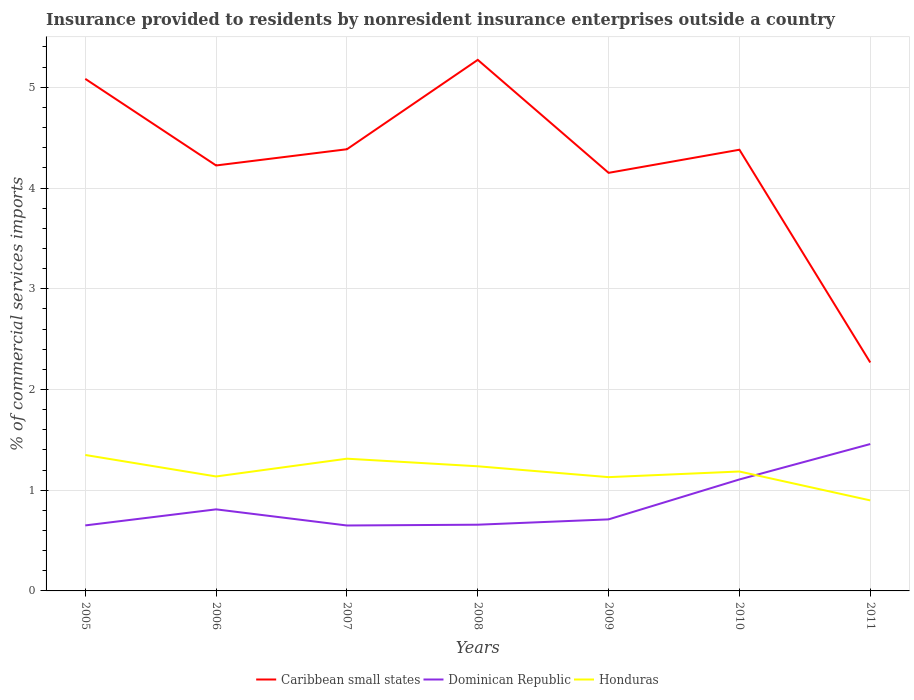How many different coloured lines are there?
Offer a terse response. 3. Does the line corresponding to Honduras intersect with the line corresponding to Caribbean small states?
Your response must be concise. No. Is the number of lines equal to the number of legend labels?
Keep it short and to the point. Yes. Across all years, what is the maximum Insurance provided to residents in Dominican Republic?
Your response must be concise. 0.65. In which year was the Insurance provided to residents in Caribbean small states maximum?
Your answer should be very brief. 2011. What is the total Insurance provided to residents in Honduras in the graph?
Give a very brief answer. 0.16. What is the difference between the highest and the second highest Insurance provided to residents in Caribbean small states?
Your response must be concise. 3. What is the difference between the highest and the lowest Insurance provided to residents in Dominican Republic?
Provide a succinct answer. 2. Is the Insurance provided to residents in Honduras strictly greater than the Insurance provided to residents in Dominican Republic over the years?
Ensure brevity in your answer.  No. How many lines are there?
Your answer should be compact. 3. What is the difference between two consecutive major ticks on the Y-axis?
Keep it short and to the point. 1. Where does the legend appear in the graph?
Offer a very short reply. Bottom center. How are the legend labels stacked?
Provide a succinct answer. Horizontal. What is the title of the graph?
Provide a succinct answer. Insurance provided to residents by nonresident insurance enterprises outside a country. Does "Cuba" appear as one of the legend labels in the graph?
Provide a short and direct response. No. What is the label or title of the X-axis?
Offer a terse response. Years. What is the label or title of the Y-axis?
Your answer should be very brief. % of commercial services imports. What is the % of commercial services imports in Caribbean small states in 2005?
Ensure brevity in your answer.  5.08. What is the % of commercial services imports of Dominican Republic in 2005?
Your answer should be very brief. 0.65. What is the % of commercial services imports in Honduras in 2005?
Ensure brevity in your answer.  1.35. What is the % of commercial services imports in Caribbean small states in 2006?
Your response must be concise. 4.22. What is the % of commercial services imports of Dominican Republic in 2006?
Ensure brevity in your answer.  0.81. What is the % of commercial services imports in Honduras in 2006?
Offer a very short reply. 1.14. What is the % of commercial services imports of Caribbean small states in 2007?
Your response must be concise. 4.38. What is the % of commercial services imports in Dominican Republic in 2007?
Your answer should be compact. 0.65. What is the % of commercial services imports of Honduras in 2007?
Offer a very short reply. 1.31. What is the % of commercial services imports in Caribbean small states in 2008?
Make the answer very short. 5.27. What is the % of commercial services imports of Dominican Republic in 2008?
Provide a short and direct response. 0.66. What is the % of commercial services imports of Honduras in 2008?
Offer a very short reply. 1.24. What is the % of commercial services imports of Caribbean small states in 2009?
Keep it short and to the point. 4.15. What is the % of commercial services imports of Dominican Republic in 2009?
Provide a short and direct response. 0.71. What is the % of commercial services imports in Honduras in 2009?
Give a very brief answer. 1.13. What is the % of commercial services imports of Caribbean small states in 2010?
Make the answer very short. 4.38. What is the % of commercial services imports in Dominican Republic in 2010?
Offer a very short reply. 1.11. What is the % of commercial services imports of Honduras in 2010?
Make the answer very short. 1.19. What is the % of commercial services imports in Caribbean small states in 2011?
Your answer should be compact. 2.27. What is the % of commercial services imports in Dominican Republic in 2011?
Offer a terse response. 1.46. What is the % of commercial services imports in Honduras in 2011?
Give a very brief answer. 0.9. Across all years, what is the maximum % of commercial services imports of Caribbean small states?
Your response must be concise. 5.27. Across all years, what is the maximum % of commercial services imports in Dominican Republic?
Your answer should be very brief. 1.46. Across all years, what is the maximum % of commercial services imports in Honduras?
Provide a succinct answer. 1.35. Across all years, what is the minimum % of commercial services imports of Caribbean small states?
Offer a terse response. 2.27. Across all years, what is the minimum % of commercial services imports of Dominican Republic?
Your answer should be compact. 0.65. Across all years, what is the minimum % of commercial services imports of Honduras?
Make the answer very short. 0.9. What is the total % of commercial services imports of Caribbean small states in the graph?
Provide a short and direct response. 29.76. What is the total % of commercial services imports of Dominican Republic in the graph?
Offer a terse response. 6.04. What is the total % of commercial services imports in Honduras in the graph?
Ensure brevity in your answer.  8.25. What is the difference between the % of commercial services imports in Caribbean small states in 2005 and that in 2006?
Ensure brevity in your answer.  0.86. What is the difference between the % of commercial services imports in Dominican Republic in 2005 and that in 2006?
Offer a very short reply. -0.16. What is the difference between the % of commercial services imports in Honduras in 2005 and that in 2006?
Offer a terse response. 0.21. What is the difference between the % of commercial services imports in Caribbean small states in 2005 and that in 2007?
Provide a short and direct response. 0.7. What is the difference between the % of commercial services imports in Dominican Republic in 2005 and that in 2007?
Offer a very short reply. 0. What is the difference between the % of commercial services imports in Honduras in 2005 and that in 2007?
Give a very brief answer. 0.04. What is the difference between the % of commercial services imports of Caribbean small states in 2005 and that in 2008?
Offer a very short reply. -0.19. What is the difference between the % of commercial services imports of Dominican Republic in 2005 and that in 2008?
Your answer should be very brief. -0.01. What is the difference between the % of commercial services imports in Honduras in 2005 and that in 2008?
Your response must be concise. 0.11. What is the difference between the % of commercial services imports of Caribbean small states in 2005 and that in 2009?
Your answer should be very brief. 0.93. What is the difference between the % of commercial services imports of Dominican Republic in 2005 and that in 2009?
Give a very brief answer. -0.06. What is the difference between the % of commercial services imports of Honduras in 2005 and that in 2009?
Your response must be concise. 0.22. What is the difference between the % of commercial services imports of Caribbean small states in 2005 and that in 2010?
Give a very brief answer. 0.7. What is the difference between the % of commercial services imports of Dominican Republic in 2005 and that in 2010?
Offer a very short reply. -0.46. What is the difference between the % of commercial services imports of Honduras in 2005 and that in 2010?
Your answer should be compact. 0.16. What is the difference between the % of commercial services imports of Caribbean small states in 2005 and that in 2011?
Offer a terse response. 2.82. What is the difference between the % of commercial services imports of Dominican Republic in 2005 and that in 2011?
Give a very brief answer. -0.81. What is the difference between the % of commercial services imports of Honduras in 2005 and that in 2011?
Keep it short and to the point. 0.45. What is the difference between the % of commercial services imports in Caribbean small states in 2006 and that in 2007?
Your response must be concise. -0.16. What is the difference between the % of commercial services imports of Dominican Republic in 2006 and that in 2007?
Ensure brevity in your answer.  0.16. What is the difference between the % of commercial services imports of Honduras in 2006 and that in 2007?
Keep it short and to the point. -0.18. What is the difference between the % of commercial services imports in Caribbean small states in 2006 and that in 2008?
Provide a short and direct response. -1.05. What is the difference between the % of commercial services imports of Dominican Republic in 2006 and that in 2008?
Offer a terse response. 0.15. What is the difference between the % of commercial services imports of Honduras in 2006 and that in 2008?
Your answer should be very brief. -0.1. What is the difference between the % of commercial services imports of Caribbean small states in 2006 and that in 2009?
Your response must be concise. 0.07. What is the difference between the % of commercial services imports in Dominican Republic in 2006 and that in 2009?
Ensure brevity in your answer.  0.1. What is the difference between the % of commercial services imports in Honduras in 2006 and that in 2009?
Your response must be concise. 0.01. What is the difference between the % of commercial services imports of Caribbean small states in 2006 and that in 2010?
Offer a terse response. -0.16. What is the difference between the % of commercial services imports in Dominican Republic in 2006 and that in 2010?
Your answer should be compact. -0.3. What is the difference between the % of commercial services imports of Honduras in 2006 and that in 2010?
Offer a terse response. -0.05. What is the difference between the % of commercial services imports of Caribbean small states in 2006 and that in 2011?
Provide a succinct answer. 1.96. What is the difference between the % of commercial services imports of Dominican Republic in 2006 and that in 2011?
Your response must be concise. -0.65. What is the difference between the % of commercial services imports in Honduras in 2006 and that in 2011?
Keep it short and to the point. 0.24. What is the difference between the % of commercial services imports of Caribbean small states in 2007 and that in 2008?
Give a very brief answer. -0.89. What is the difference between the % of commercial services imports in Dominican Republic in 2007 and that in 2008?
Offer a very short reply. -0.01. What is the difference between the % of commercial services imports of Honduras in 2007 and that in 2008?
Your answer should be compact. 0.08. What is the difference between the % of commercial services imports of Caribbean small states in 2007 and that in 2009?
Offer a terse response. 0.23. What is the difference between the % of commercial services imports in Dominican Republic in 2007 and that in 2009?
Your answer should be compact. -0.06. What is the difference between the % of commercial services imports of Honduras in 2007 and that in 2009?
Offer a terse response. 0.18. What is the difference between the % of commercial services imports of Caribbean small states in 2007 and that in 2010?
Your response must be concise. 0. What is the difference between the % of commercial services imports in Dominican Republic in 2007 and that in 2010?
Your answer should be very brief. -0.46. What is the difference between the % of commercial services imports of Honduras in 2007 and that in 2010?
Give a very brief answer. 0.13. What is the difference between the % of commercial services imports in Caribbean small states in 2007 and that in 2011?
Your answer should be compact. 2.12. What is the difference between the % of commercial services imports in Dominican Republic in 2007 and that in 2011?
Provide a succinct answer. -0.81. What is the difference between the % of commercial services imports in Honduras in 2007 and that in 2011?
Offer a terse response. 0.41. What is the difference between the % of commercial services imports in Caribbean small states in 2008 and that in 2009?
Give a very brief answer. 1.12. What is the difference between the % of commercial services imports in Dominican Republic in 2008 and that in 2009?
Make the answer very short. -0.05. What is the difference between the % of commercial services imports of Honduras in 2008 and that in 2009?
Make the answer very short. 0.11. What is the difference between the % of commercial services imports in Caribbean small states in 2008 and that in 2010?
Keep it short and to the point. 0.89. What is the difference between the % of commercial services imports of Dominican Republic in 2008 and that in 2010?
Give a very brief answer. -0.45. What is the difference between the % of commercial services imports in Honduras in 2008 and that in 2010?
Provide a succinct answer. 0.05. What is the difference between the % of commercial services imports of Caribbean small states in 2008 and that in 2011?
Ensure brevity in your answer.  3. What is the difference between the % of commercial services imports in Dominican Republic in 2008 and that in 2011?
Your answer should be very brief. -0.8. What is the difference between the % of commercial services imports of Honduras in 2008 and that in 2011?
Give a very brief answer. 0.34. What is the difference between the % of commercial services imports of Caribbean small states in 2009 and that in 2010?
Your response must be concise. -0.23. What is the difference between the % of commercial services imports of Dominican Republic in 2009 and that in 2010?
Your answer should be compact. -0.4. What is the difference between the % of commercial services imports in Honduras in 2009 and that in 2010?
Make the answer very short. -0.06. What is the difference between the % of commercial services imports in Caribbean small states in 2009 and that in 2011?
Offer a very short reply. 1.88. What is the difference between the % of commercial services imports of Dominican Republic in 2009 and that in 2011?
Provide a short and direct response. -0.75. What is the difference between the % of commercial services imports in Honduras in 2009 and that in 2011?
Your answer should be very brief. 0.23. What is the difference between the % of commercial services imports of Caribbean small states in 2010 and that in 2011?
Keep it short and to the point. 2.11. What is the difference between the % of commercial services imports in Dominican Republic in 2010 and that in 2011?
Keep it short and to the point. -0.35. What is the difference between the % of commercial services imports of Honduras in 2010 and that in 2011?
Give a very brief answer. 0.29. What is the difference between the % of commercial services imports of Caribbean small states in 2005 and the % of commercial services imports of Dominican Republic in 2006?
Make the answer very short. 4.27. What is the difference between the % of commercial services imports of Caribbean small states in 2005 and the % of commercial services imports of Honduras in 2006?
Make the answer very short. 3.95. What is the difference between the % of commercial services imports in Dominican Republic in 2005 and the % of commercial services imports in Honduras in 2006?
Provide a short and direct response. -0.49. What is the difference between the % of commercial services imports in Caribbean small states in 2005 and the % of commercial services imports in Dominican Republic in 2007?
Make the answer very short. 4.43. What is the difference between the % of commercial services imports in Caribbean small states in 2005 and the % of commercial services imports in Honduras in 2007?
Your answer should be compact. 3.77. What is the difference between the % of commercial services imports in Dominican Republic in 2005 and the % of commercial services imports in Honduras in 2007?
Offer a terse response. -0.66. What is the difference between the % of commercial services imports of Caribbean small states in 2005 and the % of commercial services imports of Dominican Republic in 2008?
Provide a short and direct response. 4.43. What is the difference between the % of commercial services imports of Caribbean small states in 2005 and the % of commercial services imports of Honduras in 2008?
Give a very brief answer. 3.85. What is the difference between the % of commercial services imports of Dominican Republic in 2005 and the % of commercial services imports of Honduras in 2008?
Your response must be concise. -0.59. What is the difference between the % of commercial services imports in Caribbean small states in 2005 and the % of commercial services imports in Dominican Republic in 2009?
Provide a succinct answer. 4.37. What is the difference between the % of commercial services imports in Caribbean small states in 2005 and the % of commercial services imports in Honduras in 2009?
Offer a very short reply. 3.95. What is the difference between the % of commercial services imports in Dominican Republic in 2005 and the % of commercial services imports in Honduras in 2009?
Offer a very short reply. -0.48. What is the difference between the % of commercial services imports in Caribbean small states in 2005 and the % of commercial services imports in Dominican Republic in 2010?
Keep it short and to the point. 3.98. What is the difference between the % of commercial services imports of Caribbean small states in 2005 and the % of commercial services imports of Honduras in 2010?
Provide a short and direct response. 3.9. What is the difference between the % of commercial services imports of Dominican Republic in 2005 and the % of commercial services imports of Honduras in 2010?
Your answer should be compact. -0.54. What is the difference between the % of commercial services imports of Caribbean small states in 2005 and the % of commercial services imports of Dominican Republic in 2011?
Provide a succinct answer. 3.63. What is the difference between the % of commercial services imports of Caribbean small states in 2005 and the % of commercial services imports of Honduras in 2011?
Your response must be concise. 4.18. What is the difference between the % of commercial services imports of Dominican Republic in 2005 and the % of commercial services imports of Honduras in 2011?
Ensure brevity in your answer.  -0.25. What is the difference between the % of commercial services imports in Caribbean small states in 2006 and the % of commercial services imports in Dominican Republic in 2007?
Provide a short and direct response. 3.57. What is the difference between the % of commercial services imports of Caribbean small states in 2006 and the % of commercial services imports of Honduras in 2007?
Make the answer very short. 2.91. What is the difference between the % of commercial services imports in Dominican Republic in 2006 and the % of commercial services imports in Honduras in 2007?
Keep it short and to the point. -0.5. What is the difference between the % of commercial services imports of Caribbean small states in 2006 and the % of commercial services imports of Dominican Republic in 2008?
Provide a succinct answer. 3.57. What is the difference between the % of commercial services imports of Caribbean small states in 2006 and the % of commercial services imports of Honduras in 2008?
Your response must be concise. 2.99. What is the difference between the % of commercial services imports of Dominican Republic in 2006 and the % of commercial services imports of Honduras in 2008?
Provide a succinct answer. -0.43. What is the difference between the % of commercial services imports in Caribbean small states in 2006 and the % of commercial services imports in Dominican Republic in 2009?
Your response must be concise. 3.51. What is the difference between the % of commercial services imports in Caribbean small states in 2006 and the % of commercial services imports in Honduras in 2009?
Provide a short and direct response. 3.09. What is the difference between the % of commercial services imports of Dominican Republic in 2006 and the % of commercial services imports of Honduras in 2009?
Provide a short and direct response. -0.32. What is the difference between the % of commercial services imports in Caribbean small states in 2006 and the % of commercial services imports in Dominican Republic in 2010?
Offer a terse response. 3.12. What is the difference between the % of commercial services imports in Caribbean small states in 2006 and the % of commercial services imports in Honduras in 2010?
Give a very brief answer. 3.04. What is the difference between the % of commercial services imports of Dominican Republic in 2006 and the % of commercial services imports of Honduras in 2010?
Make the answer very short. -0.38. What is the difference between the % of commercial services imports in Caribbean small states in 2006 and the % of commercial services imports in Dominican Republic in 2011?
Provide a short and direct response. 2.77. What is the difference between the % of commercial services imports of Caribbean small states in 2006 and the % of commercial services imports of Honduras in 2011?
Your answer should be compact. 3.33. What is the difference between the % of commercial services imports of Dominican Republic in 2006 and the % of commercial services imports of Honduras in 2011?
Ensure brevity in your answer.  -0.09. What is the difference between the % of commercial services imports of Caribbean small states in 2007 and the % of commercial services imports of Dominican Republic in 2008?
Your answer should be very brief. 3.73. What is the difference between the % of commercial services imports in Caribbean small states in 2007 and the % of commercial services imports in Honduras in 2008?
Make the answer very short. 3.15. What is the difference between the % of commercial services imports in Dominican Republic in 2007 and the % of commercial services imports in Honduras in 2008?
Make the answer very short. -0.59. What is the difference between the % of commercial services imports in Caribbean small states in 2007 and the % of commercial services imports in Dominican Republic in 2009?
Give a very brief answer. 3.67. What is the difference between the % of commercial services imports of Caribbean small states in 2007 and the % of commercial services imports of Honduras in 2009?
Provide a succinct answer. 3.26. What is the difference between the % of commercial services imports in Dominican Republic in 2007 and the % of commercial services imports in Honduras in 2009?
Your answer should be compact. -0.48. What is the difference between the % of commercial services imports of Caribbean small states in 2007 and the % of commercial services imports of Dominican Republic in 2010?
Ensure brevity in your answer.  3.28. What is the difference between the % of commercial services imports in Caribbean small states in 2007 and the % of commercial services imports in Honduras in 2010?
Provide a short and direct response. 3.2. What is the difference between the % of commercial services imports in Dominican Republic in 2007 and the % of commercial services imports in Honduras in 2010?
Keep it short and to the point. -0.54. What is the difference between the % of commercial services imports of Caribbean small states in 2007 and the % of commercial services imports of Dominican Republic in 2011?
Keep it short and to the point. 2.93. What is the difference between the % of commercial services imports of Caribbean small states in 2007 and the % of commercial services imports of Honduras in 2011?
Offer a very short reply. 3.49. What is the difference between the % of commercial services imports in Dominican Republic in 2007 and the % of commercial services imports in Honduras in 2011?
Provide a short and direct response. -0.25. What is the difference between the % of commercial services imports of Caribbean small states in 2008 and the % of commercial services imports of Dominican Republic in 2009?
Your response must be concise. 4.56. What is the difference between the % of commercial services imports of Caribbean small states in 2008 and the % of commercial services imports of Honduras in 2009?
Your answer should be compact. 4.14. What is the difference between the % of commercial services imports in Dominican Republic in 2008 and the % of commercial services imports in Honduras in 2009?
Provide a short and direct response. -0.47. What is the difference between the % of commercial services imports of Caribbean small states in 2008 and the % of commercial services imports of Dominican Republic in 2010?
Make the answer very short. 4.17. What is the difference between the % of commercial services imports in Caribbean small states in 2008 and the % of commercial services imports in Honduras in 2010?
Keep it short and to the point. 4.09. What is the difference between the % of commercial services imports of Dominican Republic in 2008 and the % of commercial services imports of Honduras in 2010?
Keep it short and to the point. -0.53. What is the difference between the % of commercial services imports of Caribbean small states in 2008 and the % of commercial services imports of Dominican Republic in 2011?
Make the answer very short. 3.81. What is the difference between the % of commercial services imports in Caribbean small states in 2008 and the % of commercial services imports in Honduras in 2011?
Your response must be concise. 4.37. What is the difference between the % of commercial services imports in Dominican Republic in 2008 and the % of commercial services imports in Honduras in 2011?
Offer a terse response. -0.24. What is the difference between the % of commercial services imports of Caribbean small states in 2009 and the % of commercial services imports of Dominican Republic in 2010?
Ensure brevity in your answer.  3.04. What is the difference between the % of commercial services imports of Caribbean small states in 2009 and the % of commercial services imports of Honduras in 2010?
Your answer should be compact. 2.96. What is the difference between the % of commercial services imports in Dominican Republic in 2009 and the % of commercial services imports in Honduras in 2010?
Offer a terse response. -0.48. What is the difference between the % of commercial services imports in Caribbean small states in 2009 and the % of commercial services imports in Dominican Republic in 2011?
Provide a succinct answer. 2.69. What is the difference between the % of commercial services imports in Caribbean small states in 2009 and the % of commercial services imports in Honduras in 2011?
Give a very brief answer. 3.25. What is the difference between the % of commercial services imports of Dominican Republic in 2009 and the % of commercial services imports of Honduras in 2011?
Your answer should be compact. -0.19. What is the difference between the % of commercial services imports of Caribbean small states in 2010 and the % of commercial services imports of Dominican Republic in 2011?
Your answer should be compact. 2.92. What is the difference between the % of commercial services imports in Caribbean small states in 2010 and the % of commercial services imports in Honduras in 2011?
Your answer should be compact. 3.48. What is the difference between the % of commercial services imports in Dominican Republic in 2010 and the % of commercial services imports in Honduras in 2011?
Provide a succinct answer. 0.21. What is the average % of commercial services imports in Caribbean small states per year?
Offer a terse response. 4.25. What is the average % of commercial services imports of Dominican Republic per year?
Offer a terse response. 0.86. What is the average % of commercial services imports of Honduras per year?
Give a very brief answer. 1.18. In the year 2005, what is the difference between the % of commercial services imports of Caribbean small states and % of commercial services imports of Dominican Republic?
Give a very brief answer. 4.43. In the year 2005, what is the difference between the % of commercial services imports of Caribbean small states and % of commercial services imports of Honduras?
Provide a short and direct response. 3.73. In the year 2005, what is the difference between the % of commercial services imports in Dominican Republic and % of commercial services imports in Honduras?
Make the answer very short. -0.7. In the year 2006, what is the difference between the % of commercial services imports of Caribbean small states and % of commercial services imports of Dominican Republic?
Give a very brief answer. 3.41. In the year 2006, what is the difference between the % of commercial services imports in Caribbean small states and % of commercial services imports in Honduras?
Offer a very short reply. 3.09. In the year 2006, what is the difference between the % of commercial services imports of Dominican Republic and % of commercial services imports of Honduras?
Provide a succinct answer. -0.33. In the year 2007, what is the difference between the % of commercial services imports in Caribbean small states and % of commercial services imports in Dominican Republic?
Your response must be concise. 3.74. In the year 2007, what is the difference between the % of commercial services imports of Caribbean small states and % of commercial services imports of Honduras?
Provide a succinct answer. 3.07. In the year 2007, what is the difference between the % of commercial services imports of Dominican Republic and % of commercial services imports of Honduras?
Make the answer very short. -0.66. In the year 2008, what is the difference between the % of commercial services imports of Caribbean small states and % of commercial services imports of Dominican Republic?
Provide a short and direct response. 4.61. In the year 2008, what is the difference between the % of commercial services imports in Caribbean small states and % of commercial services imports in Honduras?
Your answer should be compact. 4.03. In the year 2008, what is the difference between the % of commercial services imports in Dominican Republic and % of commercial services imports in Honduras?
Give a very brief answer. -0.58. In the year 2009, what is the difference between the % of commercial services imports of Caribbean small states and % of commercial services imports of Dominican Republic?
Make the answer very short. 3.44. In the year 2009, what is the difference between the % of commercial services imports of Caribbean small states and % of commercial services imports of Honduras?
Your answer should be compact. 3.02. In the year 2009, what is the difference between the % of commercial services imports of Dominican Republic and % of commercial services imports of Honduras?
Make the answer very short. -0.42. In the year 2010, what is the difference between the % of commercial services imports in Caribbean small states and % of commercial services imports in Dominican Republic?
Your answer should be compact. 3.27. In the year 2010, what is the difference between the % of commercial services imports in Caribbean small states and % of commercial services imports in Honduras?
Provide a short and direct response. 3.19. In the year 2010, what is the difference between the % of commercial services imports in Dominican Republic and % of commercial services imports in Honduras?
Your response must be concise. -0.08. In the year 2011, what is the difference between the % of commercial services imports in Caribbean small states and % of commercial services imports in Dominican Republic?
Make the answer very short. 0.81. In the year 2011, what is the difference between the % of commercial services imports of Caribbean small states and % of commercial services imports of Honduras?
Ensure brevity in your answer.  1.37. In the year 2011, what is the difference between the % of commercial services imports in Dominican Republic and % of commercial services imports in Honduras?
Your answer should be very brief. 0.56. What is the ratio of the % of commercial services imports of Caribbean small states in 2005 to that in 2006?
Keep it short and to the point. 1.2. What is the ratio of the % of commercial services imports in Dominican Republic in 2005 to that in 2006?
Offer a very short reply. 0.8. What is the ratio of the % of commercial services imports in Honduras in 2005 to that in 2006?
Make the answer very short. 1.19. What is the ratio of the % of commercial services imports of Caribbean small states in 2005 to that in 2007?
Offer a terse response. 1.16. What is the ratio of the % of commercial services imports in Dominican Republic in 2005 to that in 2007?
Your answer should be very brief. 1. What is the ratio of the % of commercial services imports in Honduras in 2005 to that in 2007?
Make the answer very short. 1.03. What is the ratio of the % of commercial services imports in Caribbean small states in 2005 to that in 2008?
Ensure brevity in your answer.  0.96. What is the ratio of the % of commercial services imports in Honduras in 2005 to that in 2008?
Ensure brevity in your answer.  1.09. What is the ratio of the % of commercial services imports of Caribbean small states in 2005 to that in 2009?
Ensure brevity in your answer.  1.22. What is the ratio of the % of commercial services imports of Dominican Republic in 2005 to that in 2009?
Offer a very short reply. 0.92. What is the ratio of the % of commercial services imports in Honduras in 2005 to that in 2009?
Your answer should be compact. 1.19. What is the ratio of the % of commercial services imports of Caribbean small states in 2005 to that in 2010?
Keep it short and to the point. 1.16. What is the ratio of the % of commercial services imports of Dominican Republic in 2005 to that in 2010?
Give a very brief answer. 0.59. What is the ratio of the % of commercial services imports in Honduras in 2005 to that in 2010?
Your answer should be very brief. 1.14. What is the ratio of the % of commercial services imports in Caribbean small states in 2005 to that in 2011?
Your answer should be compact. 2.24. What is the ratio of the % of commercial services imports of Dominican Republic in 2005 to that in 2011?
Make the answer very short. 0.45. What is the ratio of the % of commercial services imports of Honduras in 2005 to that in 2011?
Ensure brevity in your answer.  1.5. What is the ratio of the % of commercial services imports in Caribbean small states in 2006 to that in 2007?
Ensure brevity in your answer.  0.96. What is the ratio of the % of commercial services imports in Dominican Republic in 2006 to that in 2007?
Your answer should be very brief. 1.25. What is the ratio of the % of commercial services imports of Honduras in 2006 to that in 2007?
Your response must be concise. 0.87. What is the ratio of the % of commercial services imports of Caribbean small states in 2006 to that in 2008?
Provide a short and direct response. 0.8. What is the ratio of the % of commercial services imports of Dominican Republic in 2006 to that in 2008?
Your response must be concise. 1.23. What is the ratio of the % of commercial services imports in Honduras in 2006 to that in 2008?
Offer a very short reply. 0.92. What is the ratio of the % of commercial services imports in Caribbean small states in 2006 to that in 2009?
Provide a succinct answer. 1.02. What is the ratio of the % of commercial services imports of Dominican Republic in 2006 to that in 2009?
Your answer should be compact. 1.14. What is the ratio of the % of commercial services imports in Dominican Republic in 2006 to that in 2010?
Your answer should be very brief. 0.73. What is the ratio of the % of commercial services imports in Honduras in 2006 to that in 2010?
Offer a very short reply. 0.96. What is the ratio of the % of commercial services imports in Caribbean small states in 2006 to that in 2011?
Offer a very short reply. 1.86. What is the ratio of the % of commercial services imports of Dominican Republic in 2006 to that in 2011?
Ensure brevity in your answer.  0.56. What is the ratio of the % of commercial services imports of Honduras in 2006 to that in 2011?
Make the answer very short. 1.26. What is the ratio of the % of commercial services imports of Caribbean small states in 2007 to that in 2008?
Provide a short and direct response. 0.83. What is the ratio of the % of commercial services imports in Dominican Republic in 2007 to that in 2008?
Offer a terse response. 0.99. What is the ratio of the % of commercial services imports in Honduras in 2007 to that in 2008?
Provide a succinct answer. 1.06. What is the ratio of the % of commercial services imports of Caribbean small states in 2007 to that in 2009?
Your answer should be compact. 1.06. What is the ratio of the % of commercial services imports of Dominican Republic in 2007 to that in 2009?
Offer a terse response. 0.91. What is the ratio of the % of commercial services imports of Honduras in 2007 to that in 2009?
Your response must be concise. 1.16. What is the ratio of the % of commercial services imports of Dominican Republic in 2007 to that in 2010?
Offer a terse response. 0.59. What is the ratio of the % of commercial services imports of Honduras in 2007 to that in 2010?
Offer a terse response. 1.11. What is the ratio of the % of commercial services imports in Caribbean small states in 2007 to that in 2011?
Your answer should be very brief. 1.93. What is the ratio of the % of commercial services imports in Dominican Republic in 2007 to that in 2011?
Offer a very short reply. 0.45. What is the ratio of the % of commercial services imports of Honduras in 2007 to that in 2011?
Keep it short and to the point. 1.46. What is the ratio of the % of commercial services imports of Caribbean small states in 2008 to that in 2009?
Keep it short and to the point. 1.27. What is the ratio of the % of commercial services imports in Dominican Republic in 2008 to that in 2009?
Your answer should be compact. 0.93. What is the ratio of the % of commercial services imports of Honduras in 2008 to that in 2009?
Your answer should be compact. 1.1. What is the ratio of the % of commercial services imports in Caribbean small states in 2008 to that in 2010?
Make the answer very short. 1.2. What is the ratio of the % of commercial services imports in Dominican Republic in 2008 to that in 2010?
Your answer should be compact. 0.59. What is the ratio of the % of commercial services imports of Honduras in 2008 to that in 2010?
Ensure brevity in your answer.  1.04. What is the ratio of the % of commercial services imports of Caribbean small states in 2008 to that in 2011?
Make the answer very short. 2.32. What is the ratio of the % of commercial services imports in Dominican Republic in 2008 to that in 2011?
Your answer should be very brief. 0.45. What is the ratio of the % of commercial services imports in Honduras in 2008 to that in 2011?
Make the answer very short. 1.38. What is the ratio of the % of commercial services imports of Caribbean small states in 2009 to that in 2010?
Make the answer very short. 0.95. What is the ratio of the % of commercial services imports of Dominican Republic in 2009 to that in 2010?
Your answer should be very brief. 0.64. What is the ratio of the % of commercial services imports of Honduras in 2009 to that in 2010?
Give a very brief answer. 0.95. What is the ratio of the % of commercial services imports in Caribbean small states in 2009 to that in 2011?
Your answer should be very brief. 1.83. What is the ratio of the % of commercial services imports in Dominican Republic in 2009 to that in 2011?
Offer a very short reply. 0.49. What is the ratio of the % of commercial services imports of Honduras in 2009 to that in 2011?
Provide a succinct answer. 1.26. What is the ratio of the % of commercial services imports in Caribbean small states in 2010 to that in 2011?
Offer a very short reply. 1.93. What is the ratio of the % of commercial services imports of Dominican Republic in 2010 to that in 2011?
Make the answer very short. 0.76. What is the ratio of the % of commercial services imports in Honduras in 2010 to that in 2011?
Keep it short and to the point. 1.32. What is the difference between the highest and the second highest % of commercial services imports of Caribbean small states?
Your answer should be very brief. 0.19. What is the difference between the highest and the second highest % of commercial services imports of Dominican Republic?
Offer a terse response. 0.35. What is the difference between the highest and the second highest % of commercial services imports in Honduras?
Your response must be concise. 0.04. What is the difference between the highest and the lowest % of commercial services imports in Caribbean small states?
Provide a short and direct response. 3. What is the difference between the highest and the lowest % of commercial services imports of Dominican Republic?
Ensure brevity in your answer.  0.81. What is the difference between the highest and the lowest % of commercial services imports of Honduras?
Ensure brevity in your answer.  0.45. 